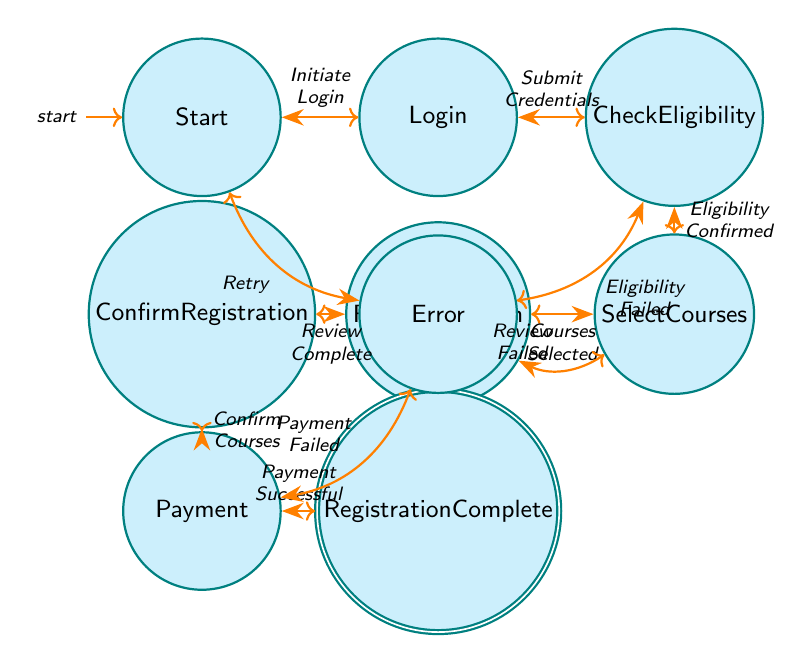What is the initial state in the registration process? The diagram starts with the initial state labeled "Start". This is indicated by the arrow pointing from nowhere to the "Start" node, which signifies where the process begins.
Answer: Start How many states are there in total? Counting the nodes in the diagram, there are nine states labeled: Start, Login, Check Eligibility, Select Courses, Review Selection, Confirm Registration, Payment, Registration Complete, and Error. Therefore, the total number of states is nine.
Answer: 9 What action leads from Check Eligibility to the Error state? The transition from "Check Eligibility" to "Error" occurs due to the action labeled "Eligibility Failed". This action specifically indicates that the student does not meet the requirements to continue.
Answer: Eligibility Failed Which state comes after Confirm Registration? From the "Confirm Registration" state, the next action leads to "Payment" as indicated by the arrow labeled "Confirm Courses." This transition shows that after confirming the selected courses, the student proceeds to payment.
Answer: Payment If eligibility fails, what state does the student return to? If the eligibility check fails, indicated by the action "Eligibility Failed," the student moves to the "Error" state. From there, they can transition back to the "Start" state by retrying the process.
Answer: Error What happens after a successful payment? After the "Payment" state, if the action labeled "Payment Successful" is taken, the flow moves to the "Registration Complete" state, indicating that the registration process has successfully concluded.
Answer: Registration Complete How many transitions are there leading to the Error state? The "Error" state can be reached through two transitions: one from "Check Eligibility" due to "Eligibility Failed" and one from "Payment" due to "Payment Failed". Therefore, there are two transitions leading to the "Error" state.
Answer: 2 What must the student do to proceed from Review Selection to Confirm Registration? To move from "Review Selection" to "Confirm Registration," the student must complete the action labeled "Review Complete". This signifies that the review process is finished and ready for confirmation.
Answer: Review Complete 